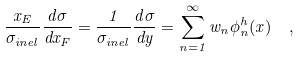Convert formula to latex. <formula><loc_0><loc_0><loc_500><loc_500>\frac { x _ { E } } { \sigma _ { i n e l } } \frac { d \sigma } { d x _ { F } } = \frac { 1 } { \sigma _ { i n e l } } \frac { d \sigma } { d y } = \sum _ { n = 1 } ^ { \infty } w _ { n } \phi _ { n } ^ { h } ( x ) \ \ ,</formula> 